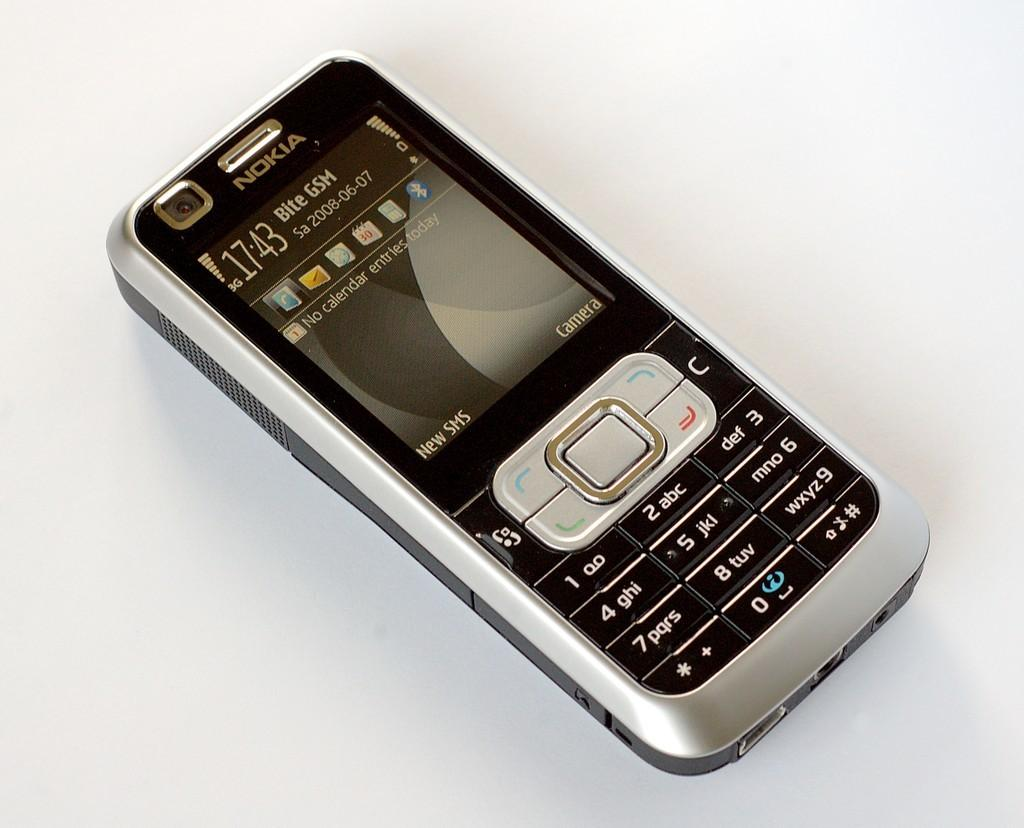What device is visible in the image? There is a mobile phone in the image. What features can be seen on the mobile phone? The mobile phone has a keypad and a screen. What is the mobile phone placed on in the image? The mobile phone is placed on a white surface. What can be found on the keys and screen of the mobile phone? There are icons, text, numbers, and symbols on the keys and screen of the mobile phone. What type of lunch is being prepared on the mobile phone in the image? There is no lunch being prepared on the mobile phone in the image; it is a device for communication and other functions. 